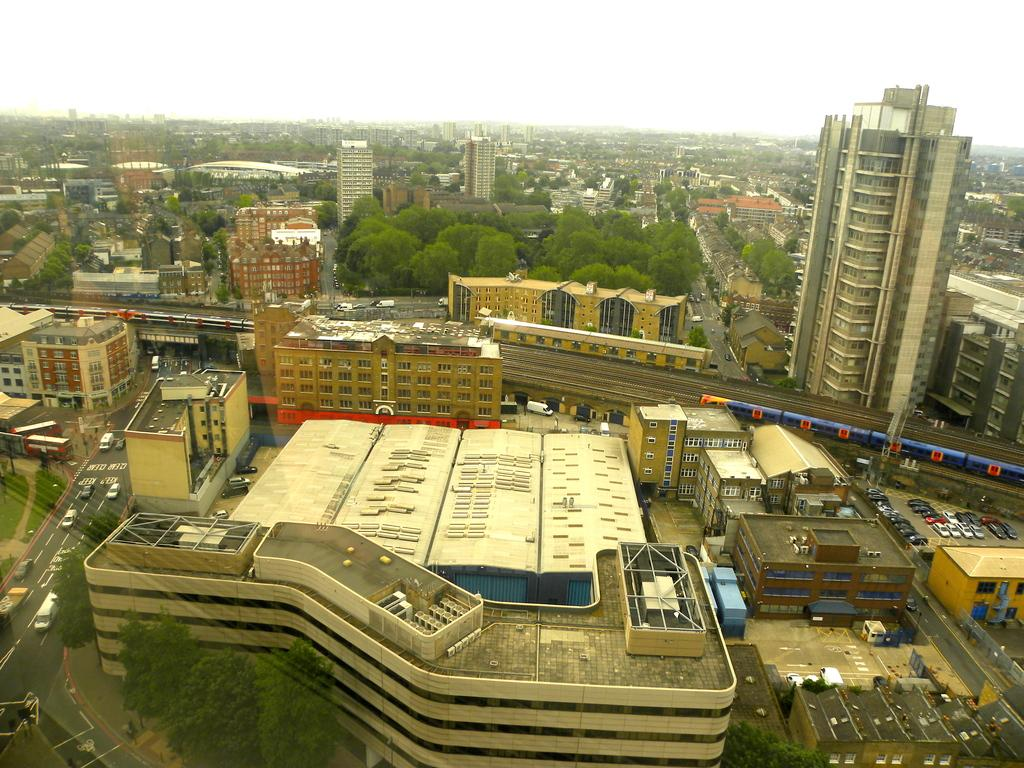What type of view is shown in the image? The image is an aerial view. What structures can be seen in the image? There are buildings, trees, a road, vehicles, a train, railway tracks, and sheds in the image. What mode of transportation is present in the image? A train is present in the image. What is the surface on which the train moves? There is a railway track in the image. What is visible at the top of the image? The sky is visible at the top of the image. What type of health issues are being discussed in the image? There is no discussion of health issues in the image; it is a view of an area with various structures and objects. What type of brick is used to construct the buildings in the image? There is no information about the type of brick used to construct the buildings in the image. 